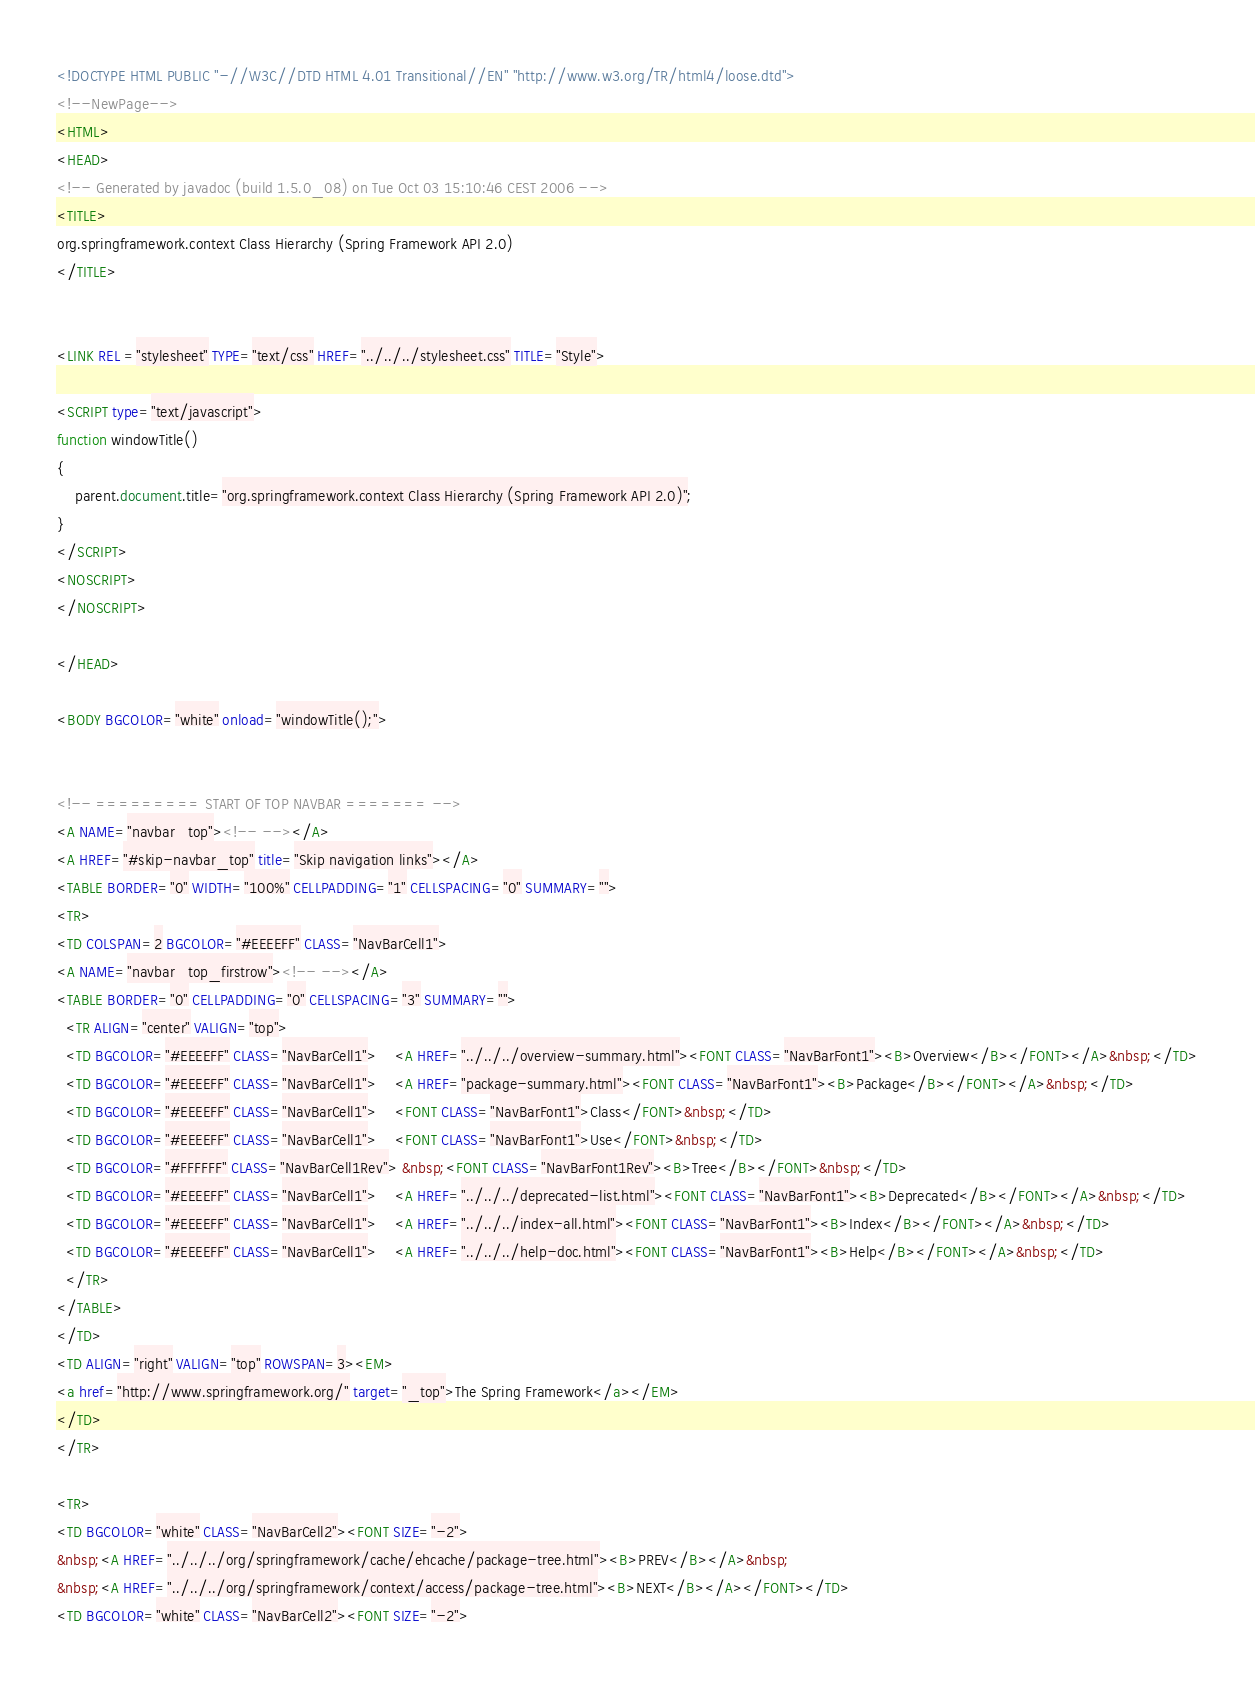<code> <loc_0><loc_0><loc_500><loc_500><_HTML_><!DOCTYPE HTML PUBLIC "-//W3C//DTD HTML 4.01 Transitional//EN" "http://www.w3.org/TR/html4/loose.dtd">
<!--NewPage-->
<HTML>
<HEAD>
<!-- Generated by javadoc (build 1.5.0_08) on Tue Oct 03 15:10:46 CEST 2006 -->
<TITLE>
org.springframework.context Class Hierarchy (Spring Framework API 2.0)
</TITLE>


<LINK REL ="stylesheet" TYPE="text/css" HREF="../../../stylesheet.css" TITLE="Style">

<SCRIPT type="text/javascript">
function windowTitle()
{
    parent.document.title="org.springframework.context Class Hierarchy (Spring Framework API 2.0)";
}
</SCRIPT>
<NOSCRIPT>
</NOSCRIPT>

</HEAD>

<BODY BGCOLOR="white" onload="windowTitle();">


<!-- ========= START OF TOP NAVBAR ======= -->
<A NAME="navbar_top"><!-- --></A>
<A HREF="#skip-navbar_top" title="Skip navigation links"></A>
<TABLE BORDER="0" WIDTH="100%" CELLPADDING="1" CELLSPACING="0" SUMMARY="">
<TR>
<TD COLSPAN=2 BGCOLOR="#EEEEFF" CLASS="NavBarCell1">
<A NAME="navbar_top_firstrow"><!-- --></A>
<TABLE BORDER="0" CELLPADDING="0" CELLSPACING="3" SUMMARY="">
  <TR ALIGN="center" VALIGN="top">
  <TD BGCOLOR="#EEEEFF" CLASS="NavBarCell1">    <A HREF="../../../overview-summary.html"><FONT CLASS="NavBarFont1"><B>Overview</B></FONT></A>&nbsp;</TD>
  <TD BGCOLOR="#EEEEFF" CLASS="NavBarCell1">    <A HREF="package-summary.html"><FONT CLASS="NavBarFont1"><B>Package</B></FONT></A>&nbsp;</TD>
  <TD BGCOLOR="#EEEEFF" CLASS="NavBarCell1">    <FONT CLASS="NavBarFont1">Class</FONT>&nbsp;</TD>
  <TD BGCOLOR="#EEEEFF" CLASS="NavBarCell1">    <FONT CLASS="NavBarFont1">Use</FONT>&nbsp;</TD>
  <TD BGCOLOR="#FFFFFF" CLASS="NavBarCell1Rev"> &nbsp;<FONT CLASS="NavBarFont1Rev"><B>Tree</B></FONT>&nbsp;</TD>
  <TD BGCOLOR="#EEEEFF" CLASS="NavBarCell1">    <A HREF="../../../deprecated-list.html"><FONT CLASS="NavBarFont1"><B>Deprecated</B></FONT></A>&nbsp;</TD>
  <TD BGCOLOR="#EEEEFF" CLASS="NavBarCell1">    <A HREF="../../../index-all.html"><FONT CLASS="NavBarFont1"><B>Index</B></FONT></A>&nbsp;</TD>
  <TD BGCOLOR="#EEEEFF" CLASS="NavBarCell1">    <A HREF="../../../help-doc.html"><FONT CLASS="NavBarFont1"><B>Help</B></FONT></A>&nbsp;</TD>
  </TR>
</TABLE>
</TD>
<TD ALIGN="right" VALIGN="top" ROWSPAN=3><EM>
<a href="http://www.springframework.org/" target="_top">The Spring Framework</a></EM>
</TD>
</TR>

<TR>
<TD BGCOLOR="white" CLASS="NavBarCell2"><FONT SIZE="-2">
&nbsp;<A HREF="../../../org/springframework/cache/ehcache/package-tree.html"><B>PREV</B></A>&nbsp;
&nbsp;<A HREF="../../../org/springframework/context/access/package-tree.html"><B>NEXT</B></A></FONT></TD>
<TD BGCOLOR="white" CLASS="NavBarCell2"><FONT SIZE="-2"></code> 